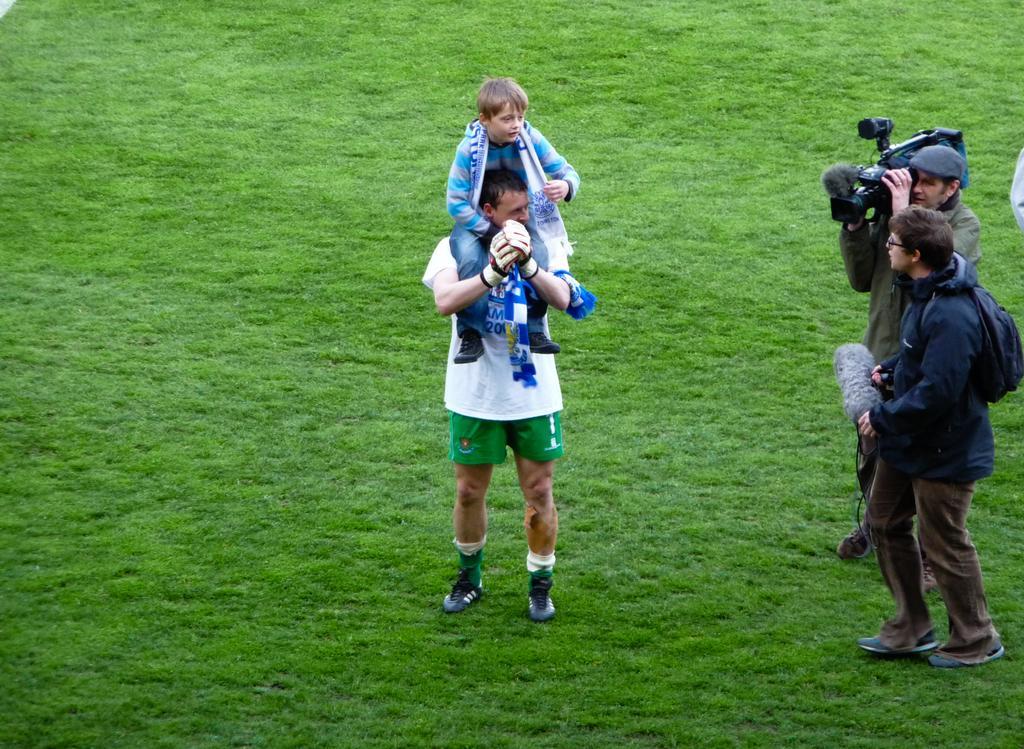How would you summarize this image in a sentence or two? In this image we can see there are people. Among one is holding a camera and the other is holding an object. There is grass.   